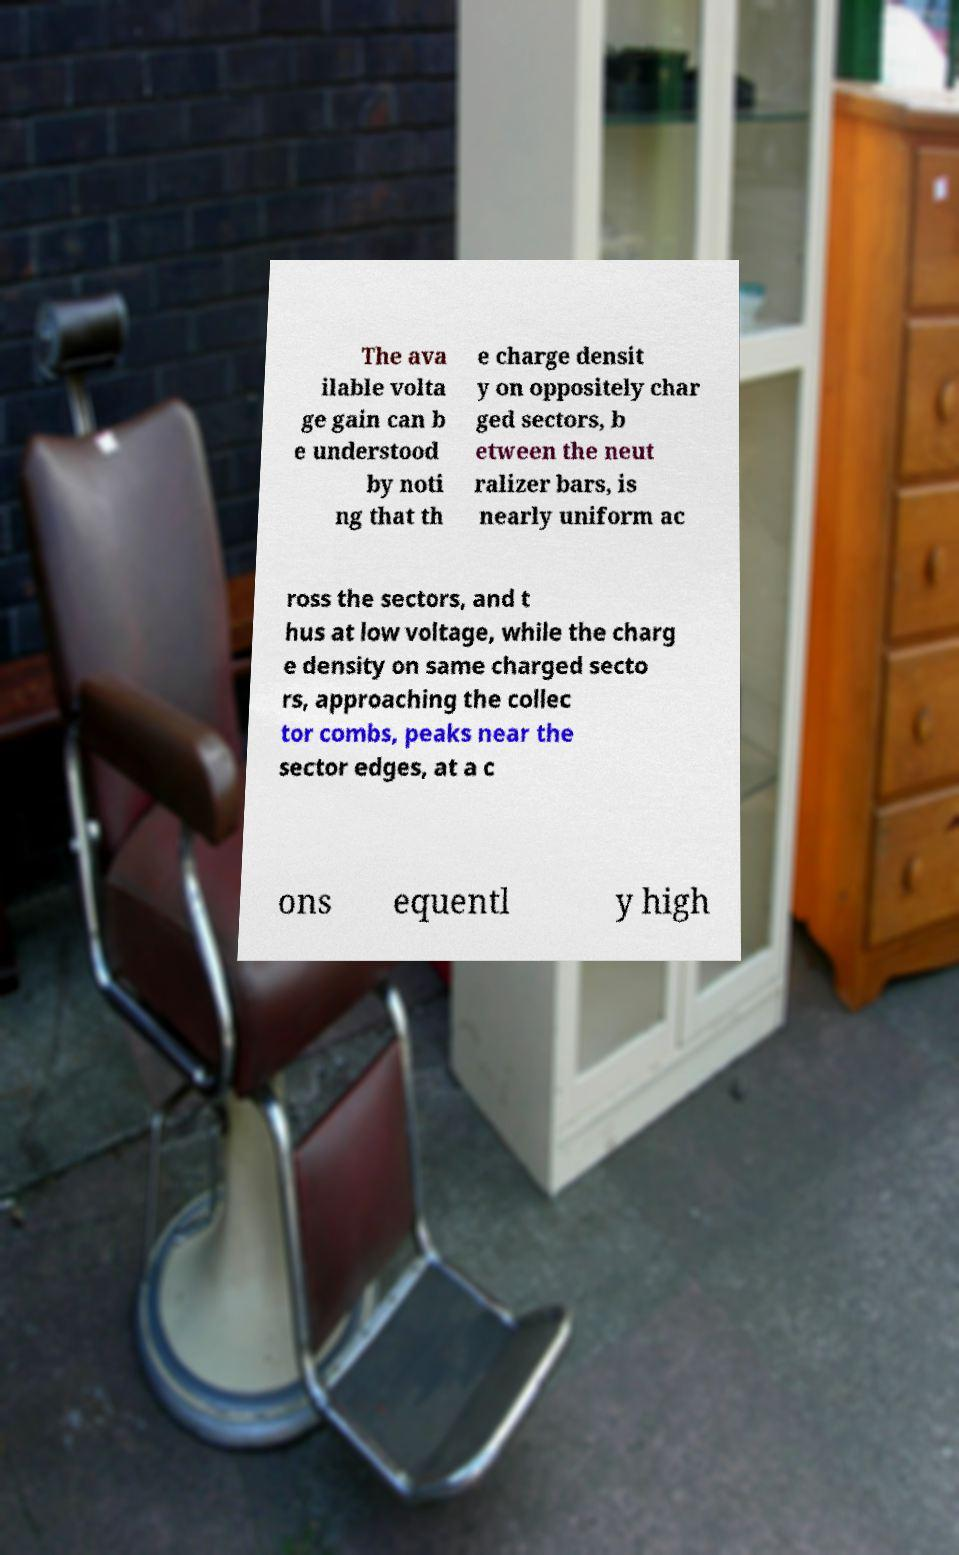Could you assist in decoding the text presented in this image and type it out clearly? The ava ilable volta ge gain can b e understood by noti ng that th e charge densit y on oppositely char ged sectors, b etween the neut ralizer bars, is nearly uniform ac ross the sectors, and t hus at low voltage, while the charg e density on same charged secto rs, approaching the collec tor combs, peaks near the sector edges, at a c ons equentl y high 